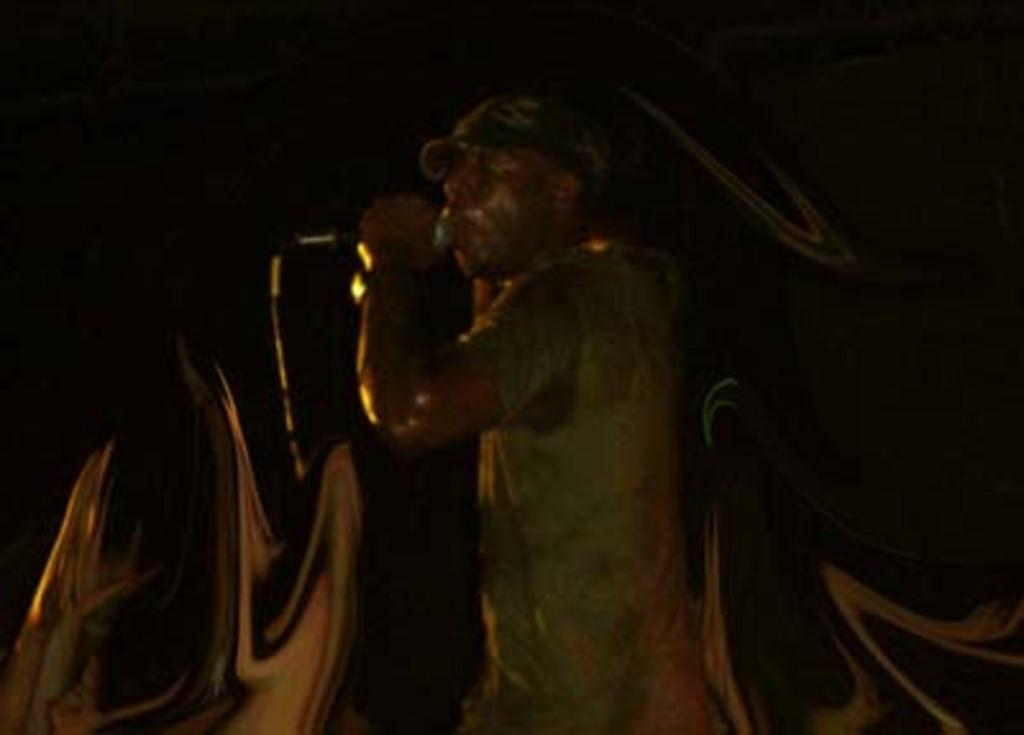Who is the main subject in the image? There is a man in the image. What is the man doing in the image? The man is standing in the image. What object is the man holding in the image? The man is holding a microphone in the image. What can be observed about the background of the image? The background of the image is dark. What type of book is the man reading in the image? There is no book present in the image, and the man is not reading. 